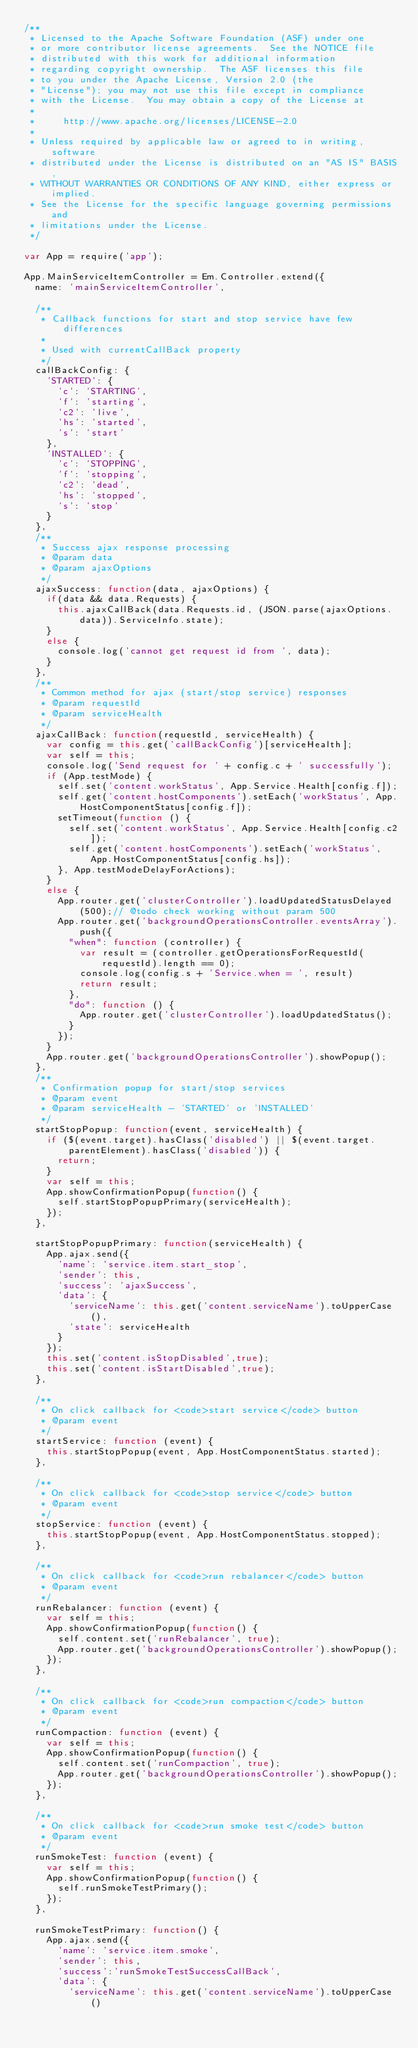Convert code to text. <code><loc_0><loc_0><loc_500><loc_500><_JavaScript_>/**
 * Licensed to the Apache Software Foundation (ASF) under one
 * or more contributor license agreements.  See the NOTICE file
 * distributed with this work for additional information
 * regarding copyright ownership.  The ASF licenses this file
 * to you under the Apache License, Version 2.0 (the
 * "License"); you may not use this file except in compliance
 * with the License.  You may obtain a copy of the License at
 *
 *     http://www.apache.org/licenses/LICENSE-2.0
 *
 * Unless required by applicable law or agreed to in writing, software
 * distributed under the License is distributed on an "AS IS" BASIS,
 * WITHOUT WARRANTIES OR CONDITIONS OF ANY KIND, either express or implied.
 * See the License for the specific language governing permissions and
 * limitations under the License.
 */

var App = require('app');

App.MainServiceItemController = Em.Controller.extend({
  name: 'mainServiceItemController',

  /**
   * Callback functions for start and stop service have few differences
   *
   * Used with currentCallBack property
   */
  callBackConfig: {
    'STARTED': {
      'c': 'STARTING',
      'f': 'starting',
      'c2': 'live',
      'hs': 'started',
      's': 'start'
    },
    'INSTALLED': {
      'c': 'STOPPING',
      'f': 'stopping',
      'c2': 'dead',
      'hs': 'stopped',
      's': 'stop'
    }
  },
  /**
   * Success ajax response processing
   * @param data
   * @param ajaxOptions
   */
  ajaxSuccess: function(data, ajaxOptions) {
    if(data && data.Requests) {
      this.ajaxCallBack(data.Requests.id, (JSON.parse(ajaxOptions.data)).ServiceInfo.state);
    }
    else {
      console.log('cannot get request id from ', data);
    }
  },
  /**
   * Common method for ajax (start/stop service) responses
   * @param requestId
   * @param serviceHealth
   */
  ajaxCallBack: function(requestId, serviceHealth) {
    var config = this.get('callBackConfig')[serviceHealth];
    var self = this;
    console.log('Send request for ' + config.c + ' successfully');
    if (App.testMode) {
      self.set('content.workStatus', App.Service.Health[config.f]);
      self.get('content.hostComponents').setEach('workStatus', App.HostComponentStatus[config.f]);
      setTimeout(function () {
        self.set('content.workStatus', App.Service.Health[config.c2]);
        self.get('content.hostComponents').setEach('workStatus', App.HostComponentStatus[config.hs]);
      }, App.testModeDelayForActions);
    }
    else {
      App.router.get('clusterController').loadUpdatedStatusDelayed(500);// @todo check working without param 500
      App.router.get('backgroundOperationsController.eventsArray').push({
        "when": function (controller) {
          var result = (controller.getOperationsForRequestId(requestId).length == 0);
          console.log(config.s + 'Service.when = ', result)
          return result;
        },
        "do": function () {
          App.router.get('clusterController').loadUpdatedStatus();
        }
      });
    }
    App.router.get('backgroundOperationsController').showPopup();
  },
  /**
   * Confirmation popup for start/stop services
   * @param event
   * @param serviceHealth - 'STARTED' or 'INSTALLED'
   */
  startStopPopup: function(event, serviceHealth) {
    if ($(event.target).hasClass('disabled') || $(event.target.parentElement).hasClass('disabled')) {
      return;
    }
    var self = this;
    App.showConfirmationPopup(function() {
      self.startStopPopupPrimary(serviceHealth);
    });
  },

  startStopPopupPrimary: function(serviceHealth) {
    App.ajax.send({
      'name': 'service.item.start_stop',
      'sender': this,
      'success': 'ajaxSuccess',
      'data': {
        'serviceName': this.get('content.serviceName').toUpperCase(),
        'state': serviceHealth
      }
    });
    this.set('content.isStopDisabled',true);
    this.set('content.isStartDisabled',true);
  },

  /**
   * On click callback for <code>start service</code> button
   * @param event
   */
  startService: function (event) {
    this.startStopPopup(event, App.HostComponentStatus.started);
  },

  /**
   * On click callback for <code>stop service</code> button
   * @param event
   */
  stopService: function (event) {
    this.startStopPopup(event, App.HostComponentStatus.stopped);
  },

  /**
   * On click callback for <code>run rebalancer</code> button
   * @param event
   */
  runRebalancer: function (event) {
    var self = this;
    App.showConfirmationPopup(function() {
      self.content.set('runRebalancer', true);
      App.router.get('backgroundOperationsController').showPopup();
    });
  },

  /**
   * On click callback for <code>run compaction</code> button
   * @param event
   */
  runCompaction: function (event) {
    var self = this;
    App.showConfirmationPopup(function() {
      self.content.set('runCompaction', true);
      App.router.get('backgroundOperationsController').showPopup();
    });
  },

  /**
   * On click callback for <code>run smoke test</code> button
   * @param event
   */
  runSmokeTest: function (event) {
    var self = this;
    App.showConfirmationPopup(function() {
      self.runSmokeTestPrimary();
    });
  },

  runSmokeTestPrimary: function() {
    App.ajax.send({
      'name': 'service.item.smoke',
      'sender': this,
      'success':'runSmokeTestSuccessCallBack',
      'data': {
        'serviceName': this.get('content.serviceName').toUpperCase()</code> 